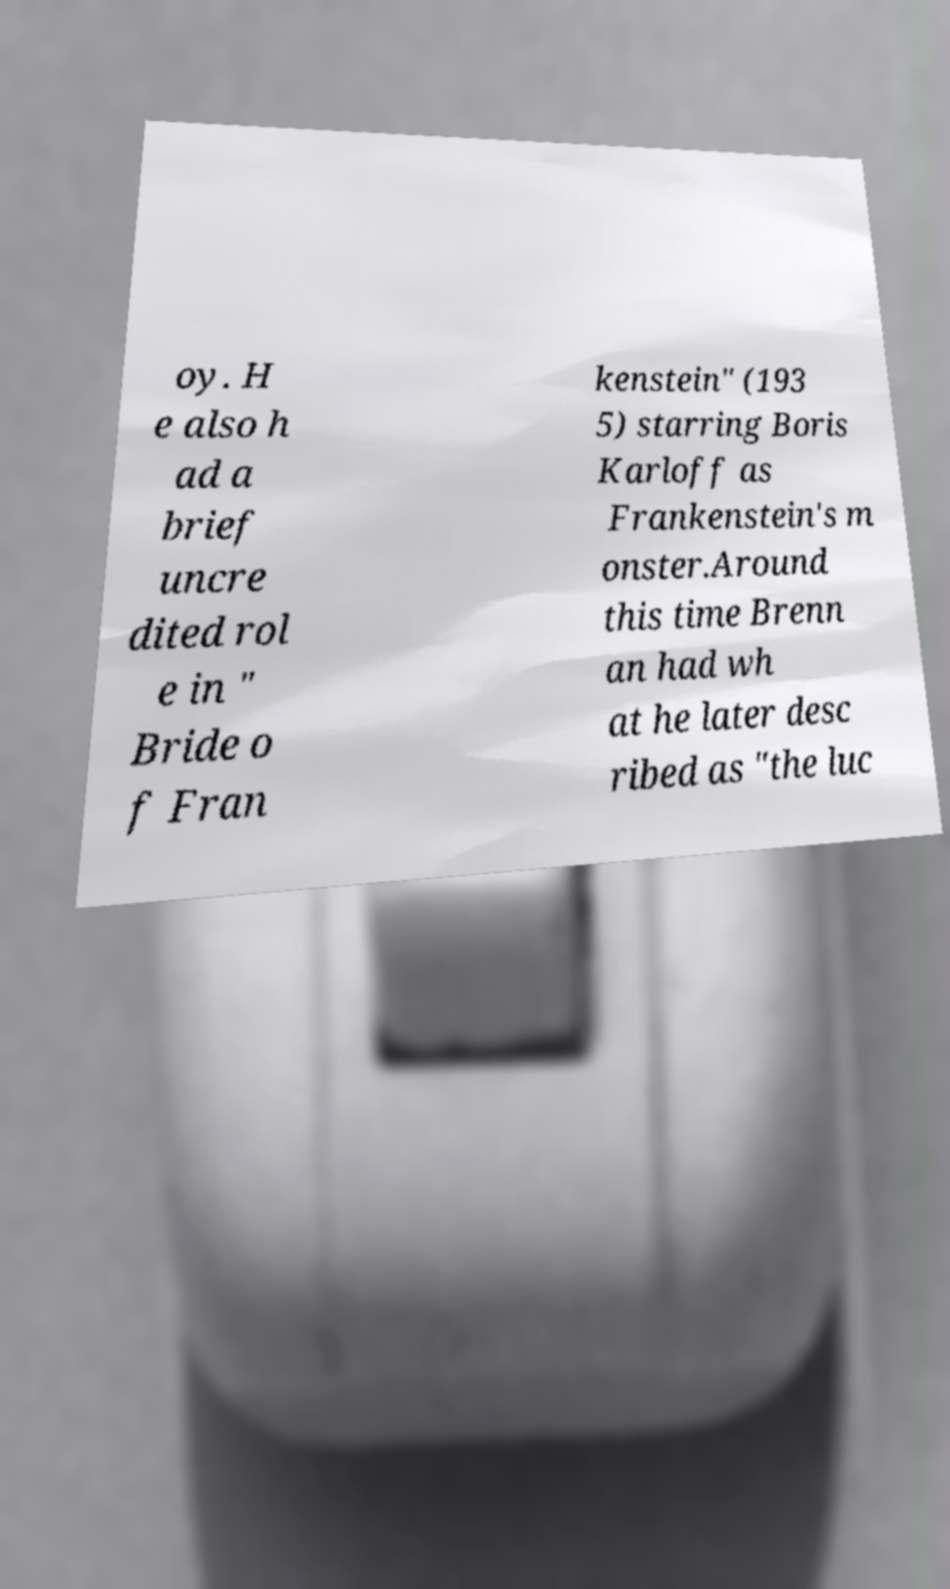What messages or text are displayed in this image? I need them in a readable, typed format. oy. H e also h ad a brief uncre dited rol e in " Bride o f Fran kenstein" (193 5) starring Boris Karloff as Frankenstein's m onster.Around this time Brenn an had wh at he later desc ribed as "the luc 